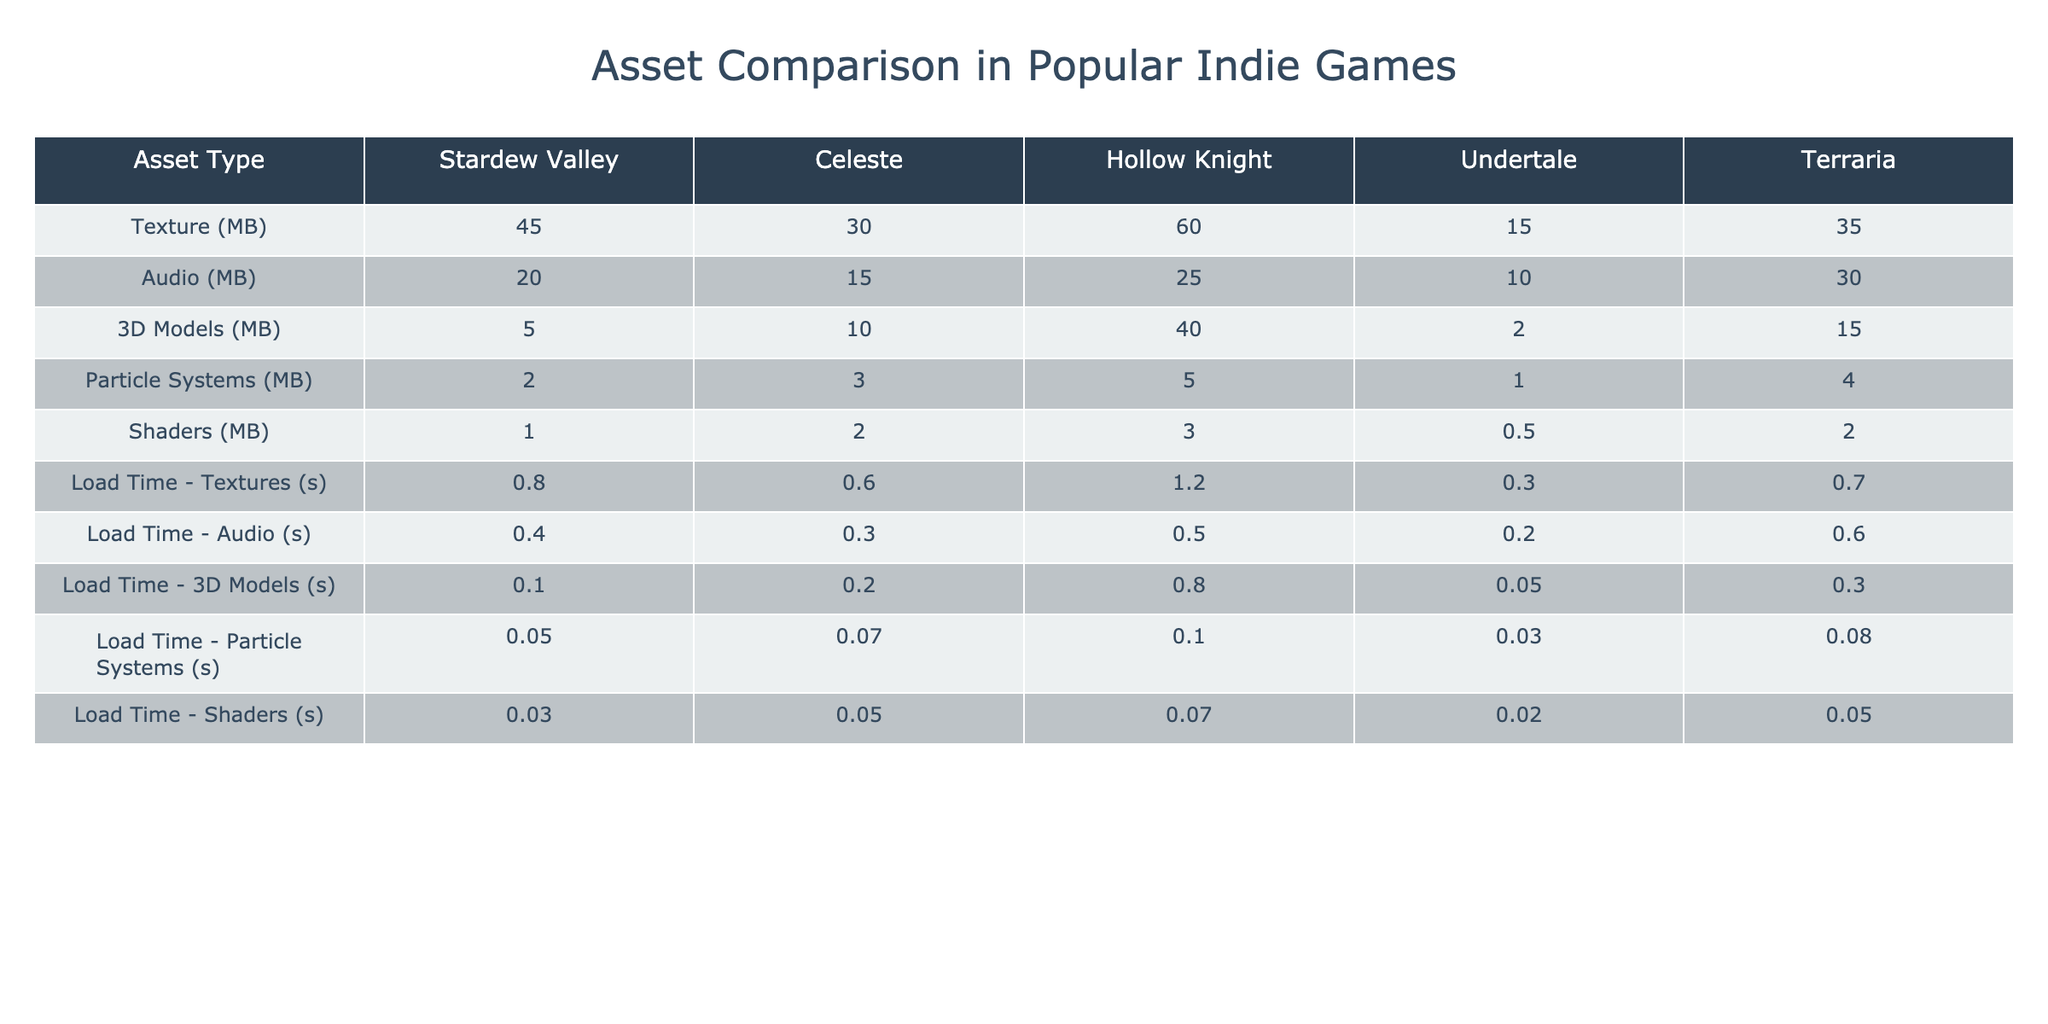What is the memory usage for 3D Models in Hollow Knight? According to the table, the memory usage for 3D Models in Hollow Knight is listed as 40 MB.
Answer: 40 MB Which indie game has the highest load time for textures? The load times for textures are 0.8 seconds for Stardew Valley, 0.6 seconds for Celeste, 1.2 seconds for Hollow Knight, 0.3 seconds for Undertale, and 0.7 seconds for Terraria. The highest load time is 1.2 seconds for Hollow Knight.
Answer: Hollow Knight How much more memory do textures use in Celeste compared to Undertale? From the table, textures in Celeste use 30 MB, while Undertale uses 15 MB. The difference is 30 MB - 15 MB = 15 MB.
Answer: 15 MB What is the total memory usage for audio across all games? The audio memory usage is: Stardew Valley (20 MB) + Celeste (15 MB) + Hollow Knight (25 MB) + Undertale (10 MB) + Terraria (30 MB) = 100 MB.
Answer: 100 MB Is the load time for audio in Stardew Valley shorter than 0.5 seconds? The load time for audio in Stardew Valley is 0.4 seconds, which is less than 0.5 seconds. Therefore, the statement is true.
Answer: Yes Which game has the lowest memory usage for particle systems? The memory usage for particle systems is as follows: Stardew Valley (2 MB), Celeste (3 MB), Hollow Knight (5 MB), Undertale (1 MB), and Terraria (4 MB). The lowest usage is 1 MB for Undertale.
Answer: Undertale What is the average load time for shaders across all the games? The load times for shaders are: Stardew Valley (0.03 s), Celeste (0.05 s), Hollow Knight (0.07 s), Undertale (0.02 s), and Terraria (0.05 s). The average load time is (0.03 + 0.05 + 0.07 + 0.02 + 0.05) / 5 = 0.044 s.
Answer: 0.044 s Which asset type has the highest memory usage in Terraria? In the table, the memory usage for various asset types in Terraria shows textures at 35 MB, audio at 30 MB, 3D models at 15 MB, particle systems at 4 MB, and shaders at 2 MB. The highest is textures at 35 MB.
Answer: Textures Calculate the total memory usage for all asset types in Celeste. From the table, the memory usage in Celeste is: Textures (30 MB) + Audio (15 MB) + 3D Models (10 MB) + Particle Systems (3 MB) + Shaders (2 MB) = 60 MB.
Answer: 60 MB Does Hollow Knight load audio faster than it loads particle systems? The load time for audio in Hollow Knight is 0.5 seconds, while for particle systems it is 0.1 seconds. Since 0.5 seconds is greater than 0.1 seconds, the statement is false.
Answer: No 